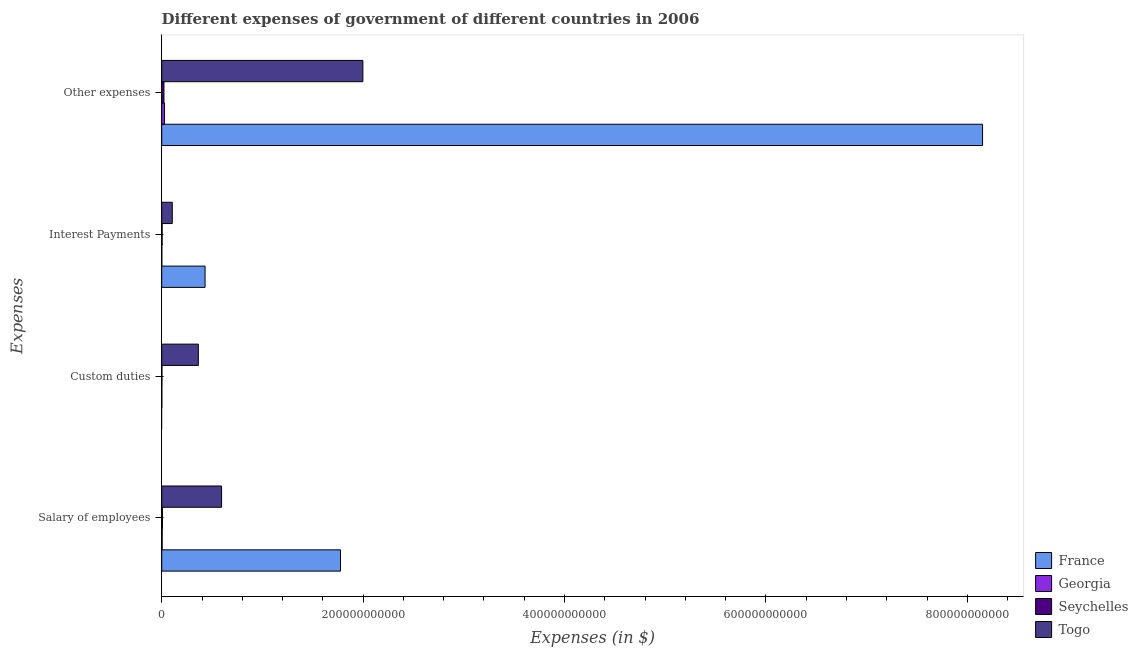How many different coloured bars are there?
Make the answer very short. 4. How many bars are there on the 4th tick from the bottom?
Make the answer very short. 4. What is the label of the 4th group of bars from the top?
Keep it short and to the point. Salary of employees. What is the amount spent on salary of employees in France?
Offer a very short reply. 1.78e+11. Across all countries, what is the maximum amount spent on salary of employees?
Provide a short and direct response. 1.78e+11. Across all countries, what is the minimum amount spent on interest payments?
Offer a very short reply. 1.00e+08. What is the total amount spent on salary of employees in the graph?
Make the answer very short. 2.38e+11. What is the difference between the amount spent on interest payments in Togo and that in Seychelles?
Offer a terse response. 1.01e+1. What is the difference between the amount spent on other expenses in Georgia and the amount spent on custom duties in Seychelles?
Make the answer very short. 2.57e+09. What is the average amount spent on salary of employees per country?
Your response must be concise. 5.95e+1. What is the difference between the amount spent on other expenses and amount spent on interest payments in Georgia?
Make the answer very short. 2.70e+09. In how many countries, is the amount spent on interest payments greater than 520000000000 $?
Provide a short and direct response. 0. What is the ratio of the amount spent on other expenses in France to that in Seychelles?
Your answer should be very brief. 366.46. Is the amount spent on other expenses in Georgia less than that in Togo?
Give a very brief answer. Yes. What is the difference between the highest and the second highest amount spent on custom duties?
Ensure brevity in your answer.  3.62e+1. What is the difference between the highest and the lowest amount spent on interest payments?
Provide a succinct answer. 4.30e+1. In how many countries, is the amount spent on other expenses greater than the average amount spent on other expenses taken over all countries?
Your answer should be compact. 1. How many bars are there?
Ensure brevity in your answer.  15. Are all the bars in the graph horizontal?
Your response must be concise. Yes. How many countries are there in the graph?
Keep it short and to the point. 4. What is the difference between two consecutive major ticks on the X-axis?
Keep it short and to the point. 2.00e+11. Are the values on the major ticks of X-axis written in scientific E-notation?
Make the answer very short. No. Does the graph contain grids?
Give a very brief answer. No. How many legend labels are there?
Offer a very short reply. 4. How are the legend labels stacked?
Give a very brief answer. Vertical. What is the title of the graph?
Your response must be concise. Different expenses of government of different countries in 2006. Does "Guam" appear as one of the legend labels in the graph?
Keep it short and to the point. No. What is the label or title of the X-axis?
Keep it short and to the point. Expenses (in $). What is the label or title of the Y-axis?
Ensure brevity in your answer.  Expenses. What is the Expenses (in $) of France in Salary of employees?
Your answer should be compact. 1.78e+11. What is the Expenses (in $) of Georgia in Salary of employees?
Provide a succinct answer. 4.52e+08. What is the Expenses (in $) in Seychelles in Salary of employees?
Ensure brevity in your answer.  7.56e+08. What is the Expenses (in $) in Togo in Salary of employees?
Make the answer very short. 5.94e+1. What is the Expenses (in $) in France in Custom duties?
Provide a short and direct response. 0. What is the Expenses (in $) of Georgia in Custom duties?
Provide a succinct answer. 1.32e+08. What is the Expenses (in $) of Seychelles in Custom duties?
Make the answer very short. 2.26e+08. What is the Expenses (in $) of Togo in Custom duties?
Your response must be concise. 3.64e+1. What is the Expenses (in $) in France in Interest Payments?
Make the answer very short. 4.31e+1. What is the Expenses (in $) in Georgia in Interest Payments?
Your response must be concise. 1.00e+08. What is the Expenses (in $) in Seychelles in Interest Payments?
Ensure brevity in your answer.  4.06e+08. What is the Expenses (in $) of Togo in Interest Payments?
Ensure brevity in your answer.  1.05e+1. What is the Expenses (in $) in France in Other expenses?
Your response must be concise. 8.15e+11. What is the Expenses (in $) in Georgia in Other expenses?
Your answer should be compact. 2.80e+09. What is the Expenses (in $) of Seychelles in Other expenses?
Your answer should be very brief. 2.22e+09. What is the Expenses (in $) of Togo in Other expenses?
Your answer should be compact. 2.00e+11. Across all Expenses, what is the maximum Expenses (in $) in France?
Offer a very short reply. 8.15e+11. Across all Expenses, what is the maximum Expenses (in $) in Georgia?
Offer a very short reply. 2.80e+09. Across all Expenses, what is the maximum Expenses (in $) of Seychelles?
Your answer should be very brief. 2.22e+09. Across all Expenses, what is the maximum Expenses (in $) of Togo?
Ensure brevity in your answer.  2.00e+11. Across all Expenses, what is the minimum Expenses (in $) in France?
Give a very brief answer. 0. Across all Expenses, what is the minimum Expenses (in $) of Georgia?
Offer a very short reply. 1.00e+08. Across all Expenses, what is the minimum Expenses (in $) of Seychelles?
Your answer should be compact. 2.26e+08. Across all Expenses, what is the minimum Expenses (in $) of Togo?
Offer a terse response. 1.05e+1. What is the total Expenses (in $) in France in the graph?
Make the answer very short. 1.04e+12. What is the total Expenses (in $) of Georgia in the graph?
Give a very brief answer. 3.48e+09. What is the total Expenses (in $) of Seychelles in the graph?
Offer a very short reply. 3.61e+09. What is the total Expenses (in $) in Togo in the graph?
Keep it short and to the point. 3.06e+11. What is the difference between the Expenses (in $) in Georgia in Salary of employees and that in Custom duties?
Give a very brief answer. 3.19e+08. What is the difference between the Expenses (in $) in Seychelles in Salary of employees and that in Custom duties?
Offer a very short reply. 5.31e+08. What is the difference between the Expenses (in $) in Togo in Salary of employees and that in Custom duties?
Make the answer very short. 2.31e+1. What is the difference between the Expenses (in $) in France in Salary of employees and that in Interest Payments?
Offer a terse response. 1.34e+11. What is the difference between the Expenses (in $) of Georgia in Salary of employees and that in Interest Payments?
Make the answer very short. 3.51e+08. What is the difference between the Expenses (in $) of Seychelles in Salary of employees and that in Interest Payments?
Your response must be concise. 3.50e+08. What is the difference between the Expenses (in $) in Togo in Salary of employees and that in Interest Payments?
Your answer should be compact. 4.89e+1. What is the difference between the Expenses (in $) of France in Salary of employees and that in Other expenses?
Offer a terse response. -6.38e+11. What is the difference between the Expenses (in $) of Georgia in Salary of employees and that in Other expenses?
Provide a succinct answer. -2.35e+09. What is the difference between the Expenses (in $) in Seychelles in Salary of employees and that in Other expenses?
Provide a short and direct response. -1.47e+09. What is the difference between the Expenses (in $) in Togo in Salary of employees and that in Other expenses?
Offer a very short reply. -1.40e+11. What is the difference between the Expenses (in $) in Georgia in Custom duties and that in Interest Payments?
Give a very brief answer. 3.19e+07. What is the difference between the Expenses (in $) in Seychelles in Custom duties and that in Interest Payments?
Your response must be concise. -1.80e+08. What is the difference between the Expenses (in $) in Togo in Custom duties and that in Interest Payments?
Your answer should be compact. 2.59e+1. What is the difference between the Expenses (in $) in Georgia in Custom duties and that in Other expenses?
Offer a very short reply. -2.67e+09. What is the difference between the Expenses (in $) in Seychelles in Custom duties and that in Other expenses?
Offer a very short reply. -2.00e+09. What is the difference between the Expenses (in $) of Togo in Custom duties and that in Other expenses?
Your answer should be compact. -1.63e+11. What is the difference between the Expenses (in $) in France in Interest Payments and that in Other expenses?
Provide a succinct answer. -7.72e+11. What is the difference between the Expenses (in $) in Georgia in Interest Payments and that in Other expenses?
Offer a very short reply. -2.70e+09. What is the difference between the Expenses (in $) of Seychelles in Interest Payments and that in Other expenses?
Provide a succinct answer. -1.82e+09. What is the difference between the Expenses (in $) of Togo in Interest Payments and that in Other expenses?
Your response must be concise. -1.89e+11. What is the difference between the Expenses (in $) of France in Salary of employees and the Expenses (in $) of Georgia in Custom duties?
Make the answer very short. 1.77e+11. What is the difference between the Expenses (in $) of France in Salary of employees and the Expenses (in $) of Seychelles in Custom duties?
Your response must be concise. 1.77e+11. What is the difference between the Expenses (in $) of France in Salary of employees and the Expenses (in $) of Togo in Custom duties?
Keep it short and to the point. 1.41e+11. What is the difference between the Expenses (in $) of Georgia in Salary of employees and the Expenses (in $) of Seychelles in Custom duties?
Offer a very short reply. 2.26e+08. What is the difference between the Expenses (in $) of Georgia in Salary of employees and the Expenses (in $) of Togo in Custom duties?
Give a very brief answer. -3.59e+1. What is the difference between the Expenses (in $) in Seychelles in Salary of employees and the Expenses (in $) in Togo in Custom duties?
Offer a terse response. -3.56e+1. What is the difference between the Expenses (in $) of France in Salary of employees and the Expenses (in $) of Georgia in Interest Payments?
Make the answer very short. 1.77e+11. What is the difference between the Expenses (in $) of France in Salary of employees and the Expenses (in $) of Seychelles in Interest Payments?
Keep it short and to the point. 1.77e+11. What is the difference between the Expenses (in $) of France in Salary of employees and the Expenses (in $) of Togo in Interest Payments?
Offer a terse response. 1.67e+11. What is the difference between the Expenses (in $) of Georgia in Salary of employees and the Expenses (in $) of Seychelles in Interest Payments?
Your response must be concise. 4.56e+07. What is the difference between the Expenses (in $) in Georgia in Salary of employees and the Expenses (in $) in Togo in Interest Payments?
Provide a succinct answer. -1.00e+1. What is the difference between the Expenses (in $) in Seychelles in Salary of employees and the Expenses (in $) in Togo in Interest Payments?
Give a very brief answer. -9.74e+09. What is the difference between the Expenses (in $) of France in Salary of employees and the Expenses (in $) of Georgia in Other expenses?
Your response must be concise. 1.75e+11. What is the difference between the Expenses (in $) of France in Salary of employees and the Expenses (in $) of Seychelles in Other expenses?
Keep it short and to the point. 1.75e+11. What is the difference between the Expenses (in $) in France in Salary of employees and the Expenses (in $) in Togo in Other expenses?
Your answer should be very brief. -2.22e+1. What is the difference between the Expenses (in $) in Georgia in Salary of employees and the Expenses (in $) in Seychelles in Other expenses?
Provide a short and direct response. -1.77e+09. What is the difference between the Expenses (in $) in Georgia in Salary of employees and the Expenses (in $) in Togo in Other expenses?
Give a very brief answer. -1.99e+11. What is the difference between the Expenses (in $) of Seychelles in Salary of employees and the Expenses (in $) of Togo in Other expenses?
Provide a short and direct response. -1.99e+11. What is the difference between the Expenses (in $) of Georgia in Custom duties and the Expenses (in $) of Seychelles in Interest Payments?
Keep it short and to the point. -2.74e+08. What is the difference between the Expenses (in $) in Georgia in Custom duties and the Expenses (in $) in Togo in Interest Payments?
Provide a succinct answer. -1.04e+1. What is the difference between the Expenses (in $) of Seychelles in Custom duties and the Expenses (in $) of Togo in Interest Payments?
Your answer should be very brief. -1.03e+1. What is the difference between the Expenses (in $) of Georgia in Custom duties and the Expenses (in $) of Seychelles in Other expenses?
Ensure brevity in your answer.  -2.09e+09. What is the difference between the Expenses (in $) of Georgia in Custom duties and the Expenses (in $) of Togo in Other expenses?
Provide a succinct answer. -2.00e+11. What is the difference between the Expenses (in $) in Seychelles in Custom duties and the Expenses (in $) in Togo in Other expenses?
Your response must be concise. -2.00e+11. What is the difference between the Expenses (in $) of France in Interest Payments and the Expenses (in $) of Georgia in Other expenses?
Give a very brief answer. 4.03e+1. What is the difference between the Expenses (in $) of France in Interest Payments and the Expenses (in $) of Seychelles in Other expenses?
Make the answer very short. 4.08e+1. What is the difference between the Expenses (in $) of France in Interest Payments and the Expenses (in $) of Togo in Other expenses?
Make the answer very short. -1.57e+11. What is the difference between the Expenses (in $) of Georgia in Interest Payments and the Expenses (in $) of Seychelles in Other expenses?
Your answer should be compact. -2.12e+09. What is the difference between the Expenses (in $) of Georgia in Interest Payments and the Expenses (in $) of Togo in Other expenses?
Offer a very short reply. -2.00e+11. What is the difference between the Expenses (in $) in Seychelles in Interest Payments and the Expenses (in $) in Togo in Other expenses?
Offer a very short reply. -1.99e+11. What is the average Expenses (in $) in France per Expenses?
Give a very brief answer. 2.59e+11. What is the average Expenses (in $) in Georgia per Expenses?
Make the answer very short. 8.71e+08. What is the average Expenses (in $) in Seychelles per Expenses?
Keep it short and to the point. 9.03e+08. What is the average Expenses (in $) in Togo per Expenses?
Your answer should be compact. 7.65e+1. What is the difference between the Expenses (in $) in France and Expenses (in $) in Georgia in Salary of employees?
Provide a succinct answer. 1.77e+11. What is the difference between the Expenses (in $) in France and Expenses (in $) in Seychelles in Salary of employees?
Keep it short and to the point. 1.77e+11. What is the difference between the Expenses (in $) in France and Expenses (in $) in Togo in Salary of employees?
Ensure brevity in your answer.  1.18e+11. What is the difference between the Expenses (in $) in Georgia and Expenses (in $) in Seychelles in Salary of employees?
Your answer should be very brief. -3.05e+08. What is the difference between the Expenses (in $) in Georgia and Expenses (in $) in Togo in Salary of employees?
Make the answer very short. -5.90e+1. What is the difference between the Expenses (in $) of Seychelles and Expenses (in $) of Togo in Salary of employees?
Offer a terse response. -5.87e+1. What is the difference between the Expenses (in $) of Georgia and Expenses (in $) of Seychelles in Custom duties?
Offer a terse response. -9.31e+07. What is the difference between the Expenses (in $) of Georgia and Expenses (in $) of Togo in Custom duties?
Keep it short and to the point. -3.62e+1. What is the difference between the Expenses (in $) of Seychelles and Expenses (in $) of Togo in Custom duties?
Provide a succinct answer. -3.62e+1. What is the difference between the Expenses (in $) of France and Expenses (in $) of Georgia in Interest Payments?
Your answer should be very brief. 4.30e+1. What is the difference between the Expenses (in $) of France and Expenses (in $) of Seychelles in Interest Payments?
Give a very brief answer. 4.27e+1. What is the difference between the Expenses (in $) of France and Expenses (in $) of Togo in Interest Payments?
Offer a very short reply. 3.26e+1. What is the difference between the Expenses (in $) in Georgia and Expenses (in $) in Seychelles in Interest Payments?
Provide a succinct answer. -3.05e+08. What is the difference between the Expenses (in $) of Georgia and Expenses (in $) of Togo in Interest Payments?
Keep it short and to the point. -1.04e+1. What is the difference between the Expenses (in $) in Seychelles and Expenses (in $) in Togo in Interest Payments?
Make the answer very short. -1.01e+1. What is the difference between the Expenses (in $) of France and Expenses (in $) of Georgia in Other expenses?
Make the answer very short. 8.12e+11. What is the difference between the Expenses (in $) of France and Expenses (in $) of Seychelles in Other expenses?
Your answer should be very brief. 8.13e+11. What is the difference between the Expenses (in $) in France and Expenses (in $) in Togo in Other expenses?
Offer a very short reply. 6.15e+11. What is the difference between the Expenses (in $) of Georgia and Expenses (in $) of Seychelles in Other expenses?
Make the answer very short. 5.76e+08. What is the difference between the Expenses (in $) in Georgia and Expenses (in $) in Togo in Other expenses?
Offer a very short reply. -1.97e+11. What is the difference between the Expenses (in $) in Seychelles and Expenses (in $) in Togo in Other expenses?
Ensure brevity in your answer.  -1.98e+11. What is the ratio of the Expenses (in $) of Georgia in Salary of employees to that in Custom duties?
Make the answer very short. 3.41. What is the ratio of the Expenses (in $) of Seychelles in Salary of employees to that in Custom duties?
Offer a very short reply. 3.35. What is the ratio of the Expenses (in $) of Togo in Salary of employees to that in Custom duties?
Make the answer very short. 1.63. What is the ratio of the Expenses (in $) of France in Salary of employees to that in Interest Payments?
Your answer should be very brief. 4.12. What is the ratio of the Expenses (in $) in Georgia in Salary of employees to that in Interest Payments?
Make the answer very short. 4.49. What is the ratio of the Expenses (in $) of Seychelles in Salary of employees to that in Interest Payments?
Give a very brief answer. 1.86. What is the ratio of the Expenses (in $) of Togo in Salary of employees to that in Interest Payments?
Your response must be concise. 5.66. What is the ratio of the Expenses (in $) in France in Salary of employees to that in Other expenses?
Provide a succinct answer. 0.22. What is the ratio of the Expenses (in $) of Georgia in Salary of employees to that in Other expenses?
Your response must be concise. 0.16. What is the ratio of the Expenses (in $) of Seychelles in Salary of employees to that in Other expenses?
Provide a succinct answer. 0.34. What is the ratio of the Expenses (in $) in Togo in Salary of employees to that in Other expenses?
Provide a short and direct response. 0.3. What is the ratio of the Expenses (in $) in Georgia in Custom duties to that in Interest Payments?
Your answer should be very brief. 1.32. What is the ratio of the Expenses (in $) of Seychelles in Custom duties to that in Interest Payments?
Offer a very short reply. 0.56. What is the ratio of the Expenses (in $) of Togo in Custom duties to that in Interest Payments?
Offer a terse response. 3.47. What is the ratio of the Expenses (in $) of Georgia in Custom duties to that in Other expenses?
Offer a very short reply. 0.05. What is the ratio of the Expenses (in $) in Seychelles in Custom duties to that in Other expenses?
Your answer should be very brief. 0.1. What is the ratio of the Expenses (in $) in Togo in Custom duties to that in Other expenses?
Offer a terse response. 0.18. What is the ratio of the Expenses (in $) of France in Interest Payments to that in Other expenses?
Your answer should be very brief. 0.05. What is the ratio of the Expenses (in $) of Georgia in Interest Payments to that in Other expenses?
Your response must be concise. 0.04. What is the ratio of the Expenses (in $) in Seychelles in Interest Payments to that in Other expenses?
Give a very brief answer. 0.18. What is the ratio of the Expenses (in $) in Togo in Interest Payments to that in Other expenses?
Ensure brevity in your answer.  0.05. What is the difference between the highest and the second highest Expenses (in $) in France?
Offer a terse response. 6.38e+11. What is the difference between the highest and the second highest Expenses (in $) of Georgia?
Give a very brief answer. 2.35e+09. What is the difference between the highest and the second highest Expenses (in $) in Seychelles?
Offer a very short reply. 1.47e+09. What is the difference between the highest and the second highest Expenses (in $) of Togo?
Your answer should be compact. 1.40e+11. What is the difference between the highest and the lowest Expenses (in $) in France?
Make the answer very short. 8.15e+11. What is the difference between the highest and the lowest Expenses (in $) in Georgia?
Offer a terse response. 2.70e+09. What is the difference between the highest and the lowest Expenses (in $) of Seychelles?
Give a very brief answer. 2.00e+09. What is the difference between the highest and the lowest Expenses (in $) of Togo?
Your answer should be compact. 1.89e+11. 